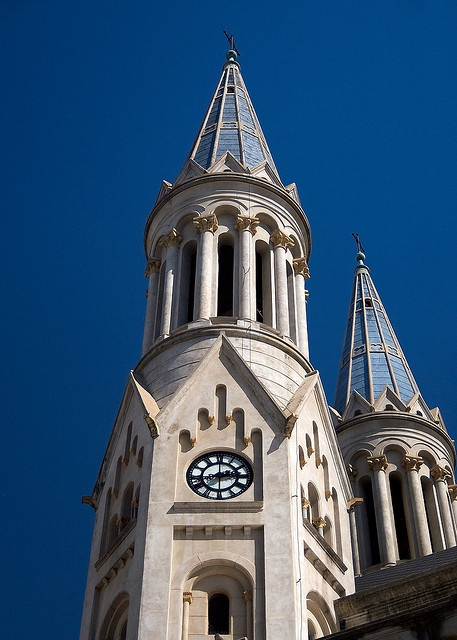Describe the objects in this image and their specific colors. I can see a clock in navy, black, lightgray, gray, and darkgray tones in this image. 